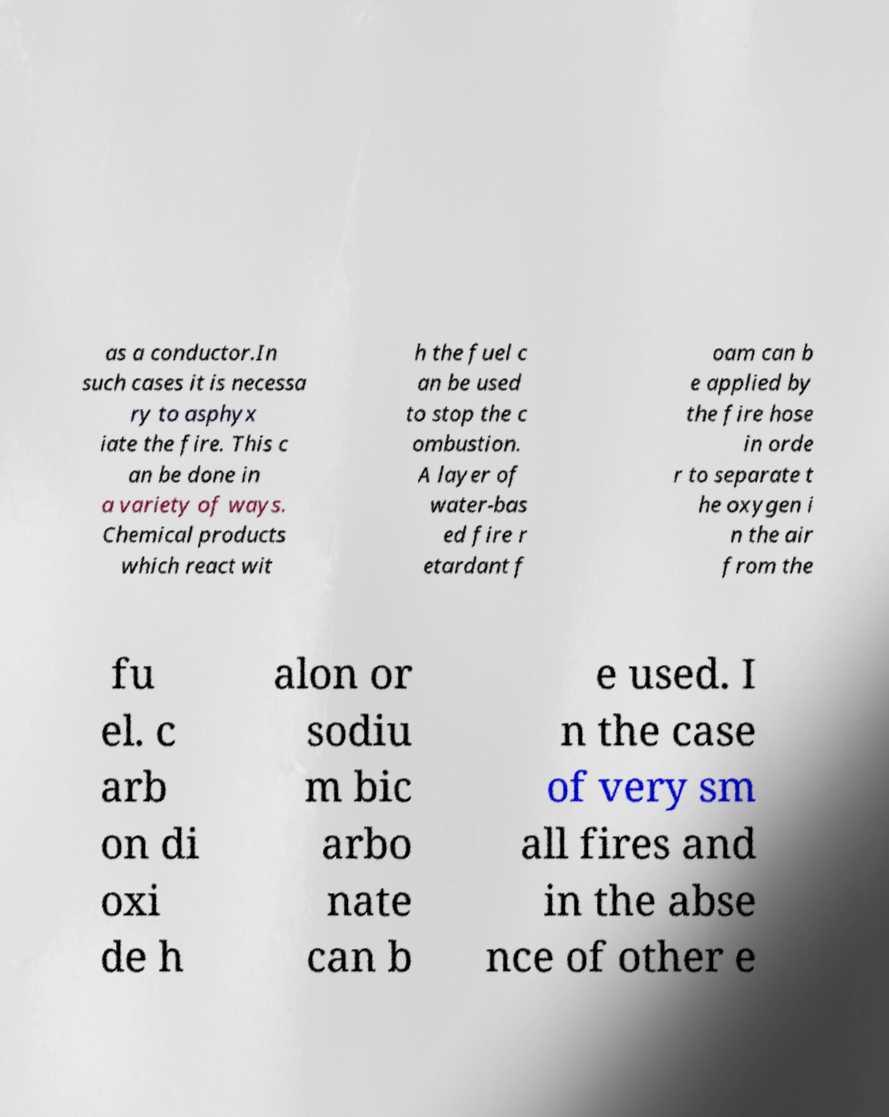Can you read and provide the text displayed in the image?This photo seems to have some interesting text. Can you extract and type it out for me? as a conductor.In such cases it is necessa ry to asphyx iate the fire. This c an be done in a variety of ways. Chemical products which react wit h the fuel c an be used to stop the c ombustion. A layer of water-bas ed fire r etardant f oam can b e applied by the fire hose in orde r to separate t he oxygen i n the air from the fu el. c arb on di oxi de h alon or sodiu m bic arbo nate can b e used. I n the case of very sm all fires and in the abse nce of other e 